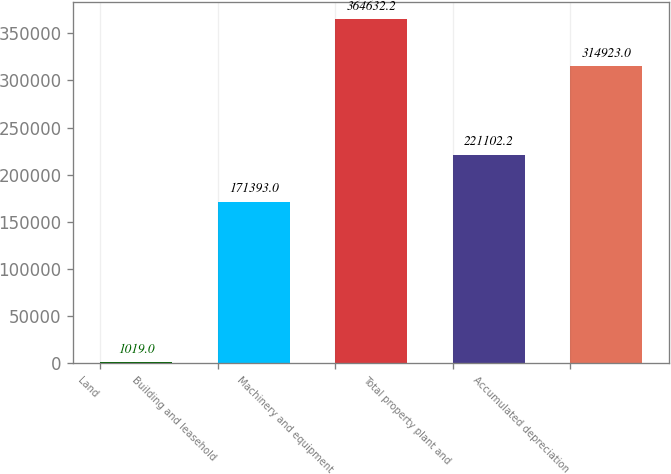Convert chart to OTSL. <chart><loc_0><loc_0><loc_500><loc_500><bar_chart><fcel>Land<fcel>Building and leasehold<fcel>Machinery and equipment<fcel>Total property plant and<fcel>Accumulated depreciation<nl><fcel>1019<fcel>171393<fcel>364632<fcel>221102<fcel>314923<nl></chart> 